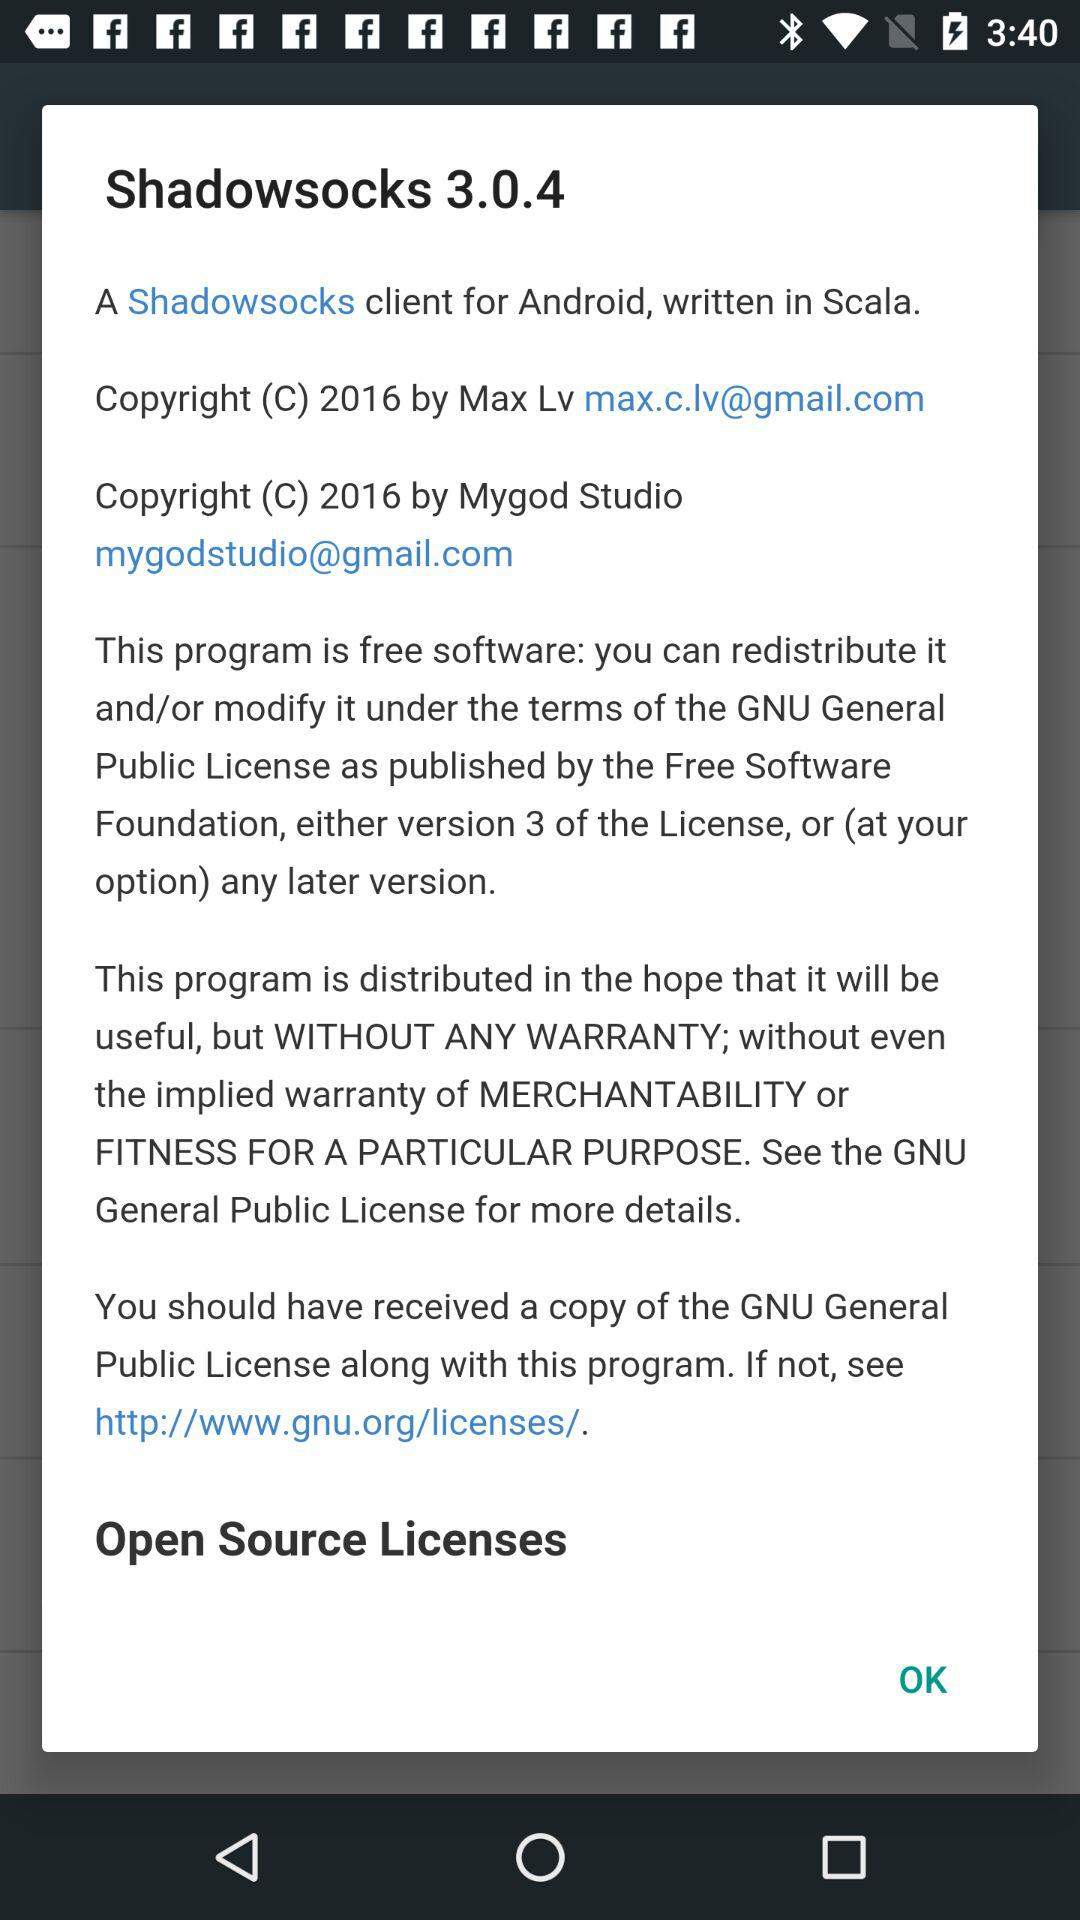What is the email address of "Mygod Studio"? The email address is mygodstudio@gmail.com. 